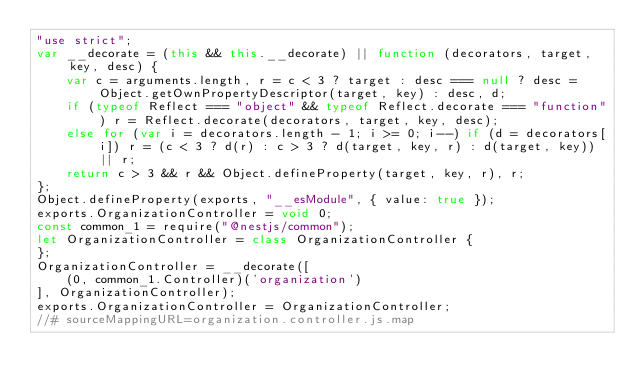Convert code to text. <code><loc_0><loc_0><loc_500><loc_500><_JavaScript_>"use strict";
var __decorate = (this && this.__decorate) || function (decorators, target, key, desc) {
    var c = arguments.length, r = c < 3 ? target : desc === null ? desc = Object.getOwnPropertyDescriptor(target, key) : desc, d;
    if (typeof Reflect === "object" && typeof Reflect.decorate === "function") r = Reflect.decorate(decorators, target, key, desc);
    else for (var i = decorators.length - 1; i >= 0; i--) if (d = decorators[i]) r = (c < 3 ? d(r) : c > 3 ? d(target, key, r) : d(target, key)) || r;
    return c > 3 && r && Object.defineProperty(target, key, r), r;
};
Object.defineProperty(exports, "__esModule", { value: true });
exports.OrganizationController = void 0;
const common_1 = require("@nestjs/common");
let OrganizationController = class OrganizationController {
};
OrganizationController = __decorate([
    (0, common_1.Controller)('organization')
], OrganizationController);
exports.OrganizationController = OrganizationController;
//# sourceMappingURL=organization.controller.js.map</code> 